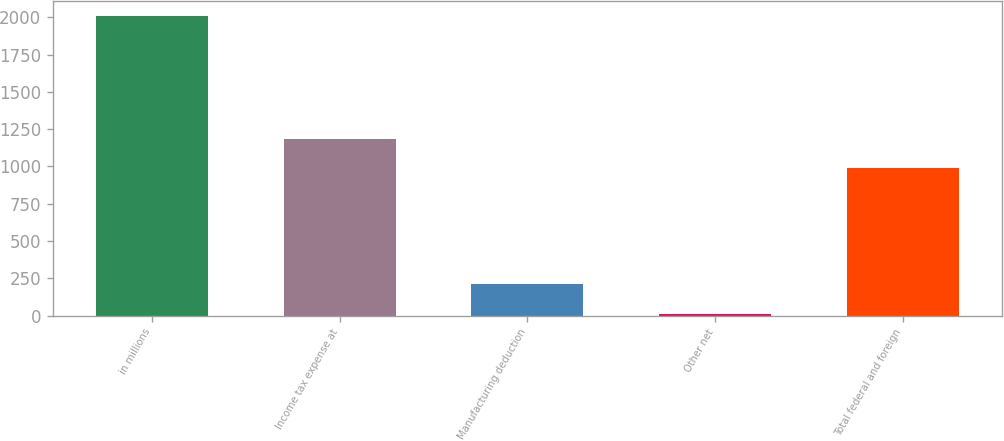Convert chart. <chart><loc_0><loc_0><loc_500><loc_500><bar_chart><fcel>in millions<fcel>Income tax expense at<fcel>Manufacturing deduction<fcel>Other net<fcel>Total federal and foreign<nl><fcel>2012<fcel>1187.3<fcel>209.3<fcel>9<fcel>987<nl></chart> 